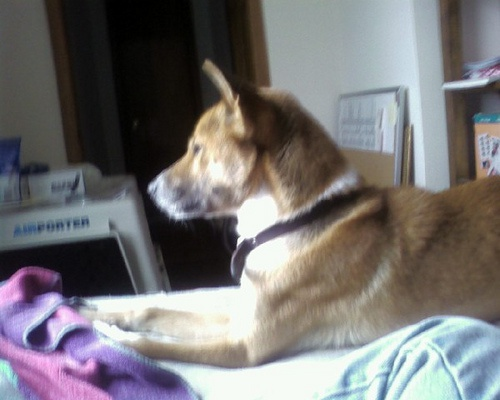Describe the objects in this image and their specific colors. I can see dog in gray, ivory, maroon, and darkgray tones, bed in gray, ivory, darkgray, lightblue, and violet tones, book in gray, lightblue, darkgray, and lightgray tones, and book in gray and darkgray tones in this image. 